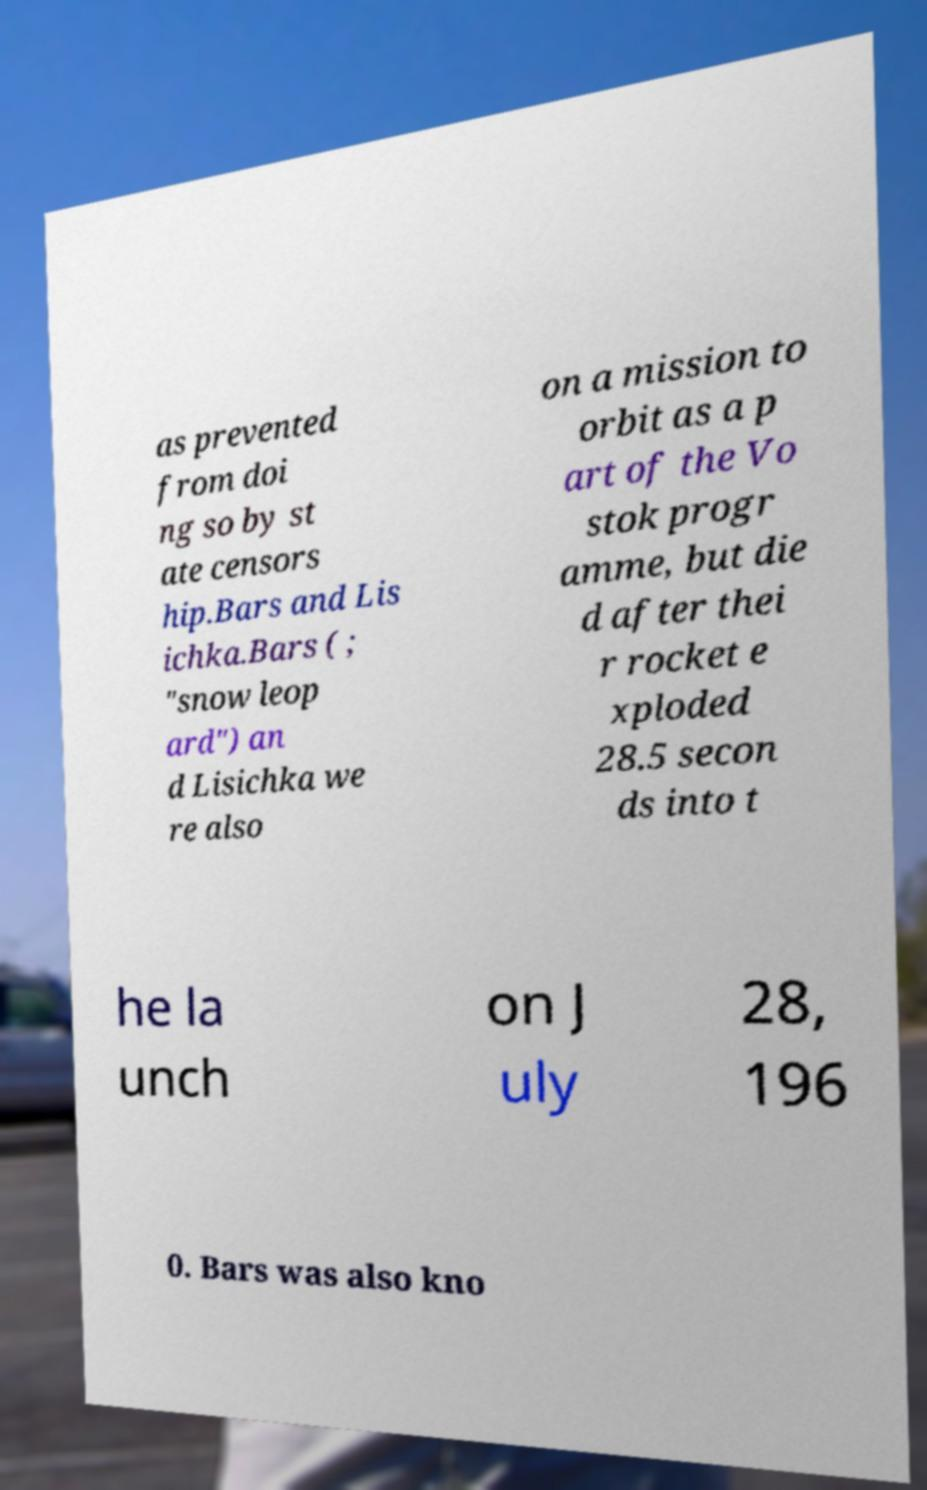Can you read and provide the text displayed in the image?This photo seems to have some interesting text. Can you extract and type it out for me? as prevented from doi ng so by st ate censors hip.Bars and Lis ichka.Bars ( ; "snow leop ard") an d Lisichka we re also on a mission to orbit as a p art of the Vo stok progr amme, but die d after thei r rocket e xploded 28.5 secon ds into t he la unch on J uly 28, 196 0. Bars was also kno 